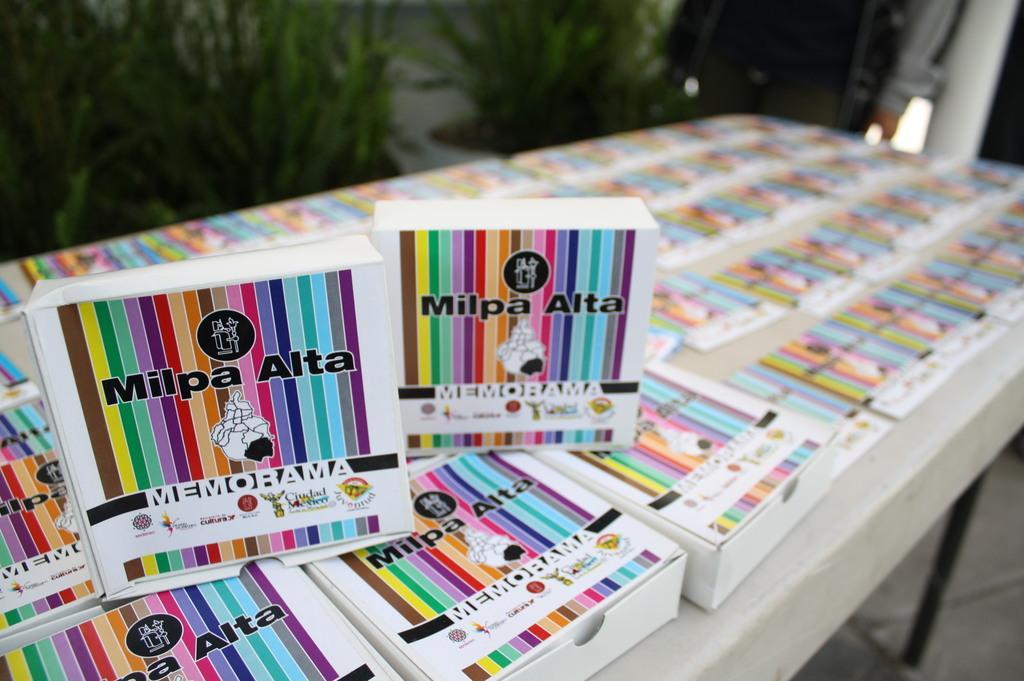Can you describe this image briefly? In this image I see lot of books on the table. In the background I see few plants. 